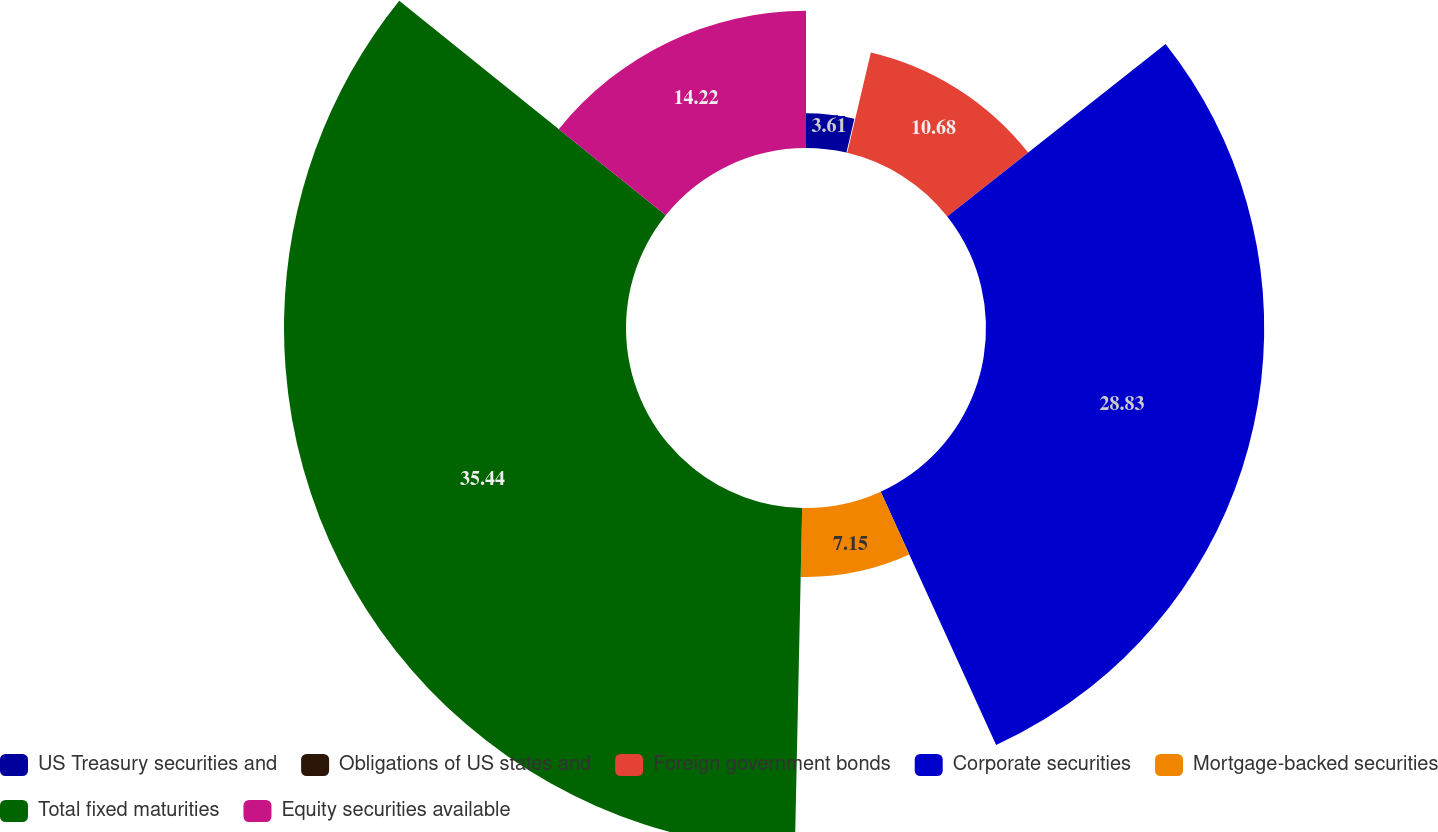<chart> <loc_0><loc_0><loc_500><loc_500><pie_chart><fcel>US Treasury securities and<fcel>Obligations of US states and<fcel>Foreign government bonds<fcel>Corporate securities<fcel>Mortgage-backed securities<fcel>Total fixed maturities<fcel>Equity securities available<nl><fcel>3.61%<fcel>0.07%<fcel>10.68%<fcel>28.83%<fcel>7.15%<fcel>35.44%<fcel>14.22%<nl></chart> 